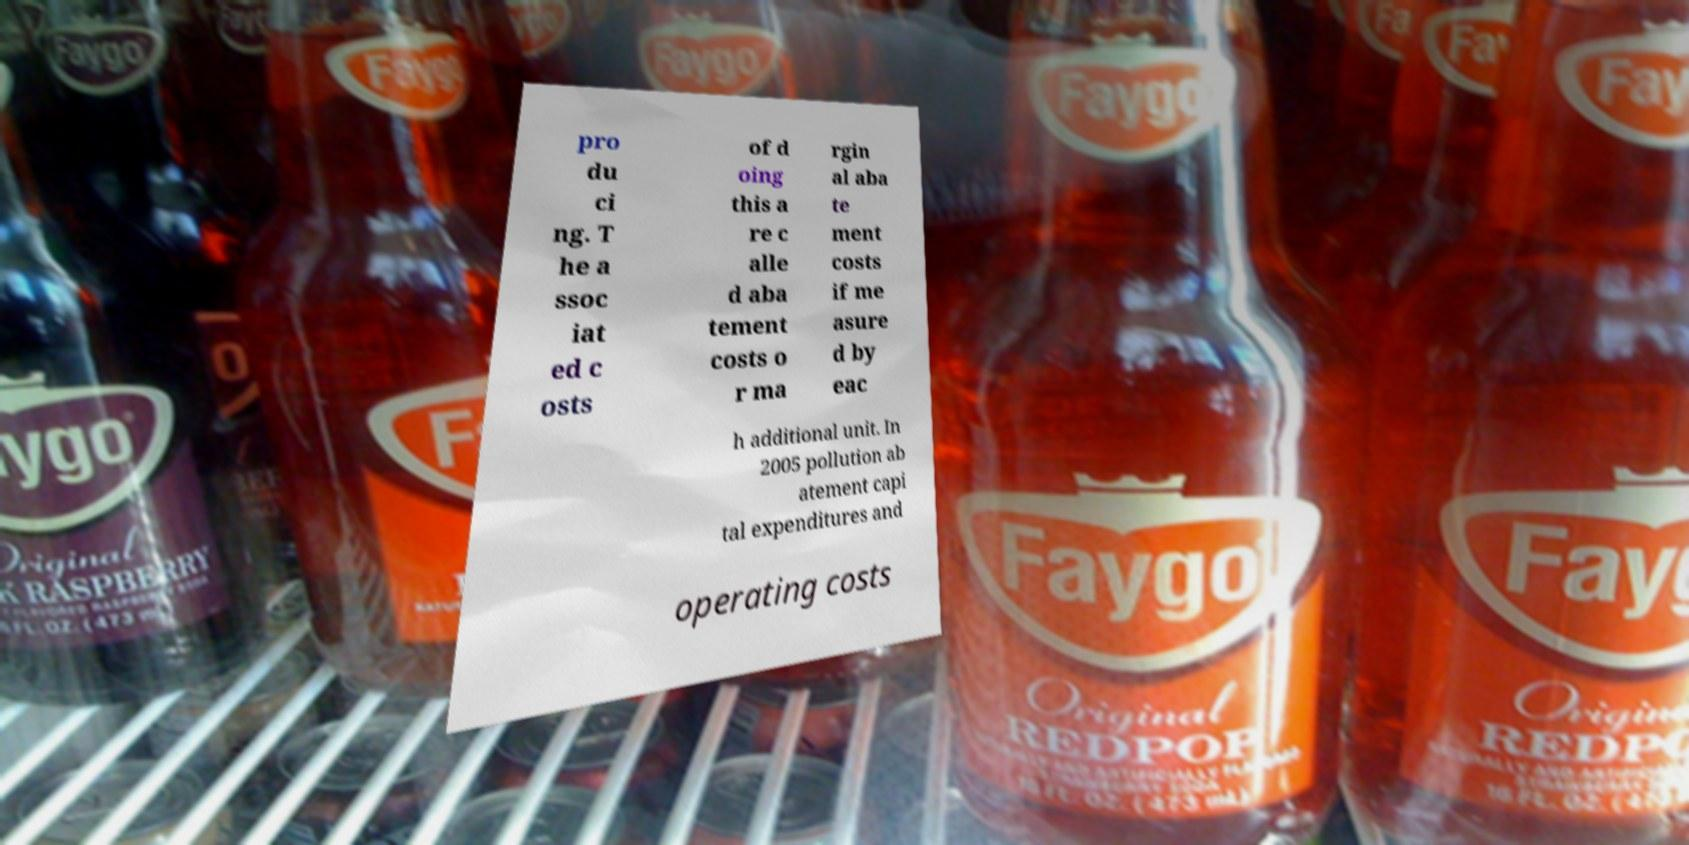Can you read and provide the text displayed in the image?This photo seems to have some interesting text. Can you extract and type it out for me? pro du ci ng. T he a ssoc iat ed c osts of d oing this a re c alle d aba tement costs o r ma rgin al aba te ment costs if me asure d by eac h additional unit. In 2005 pollution ab atement capi tal expenditures and operating costs 